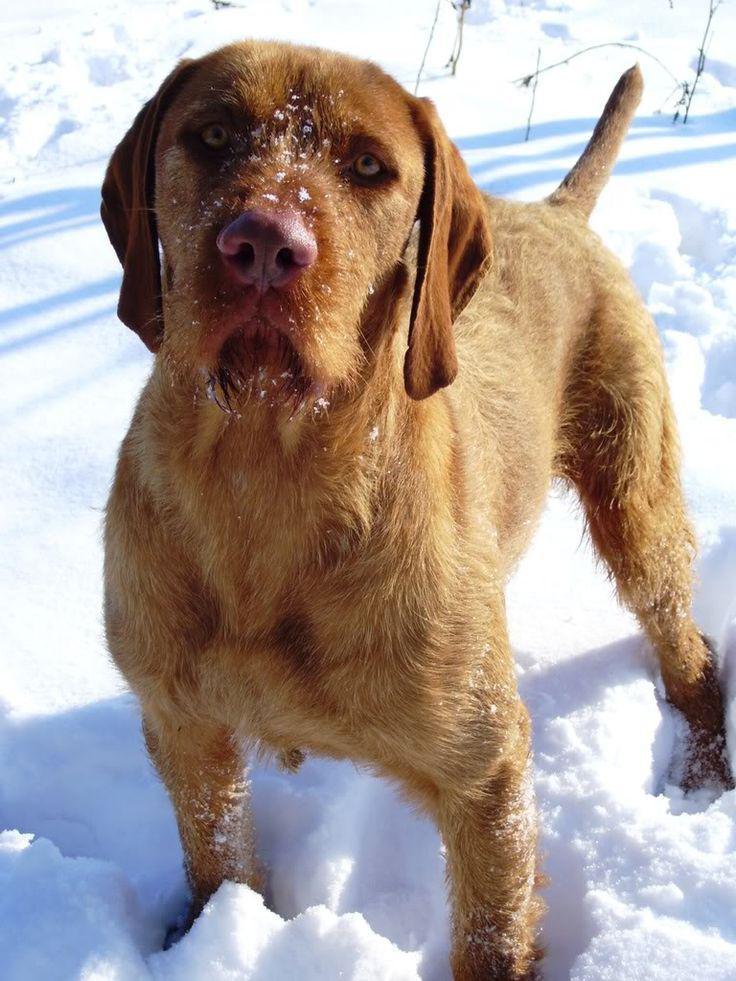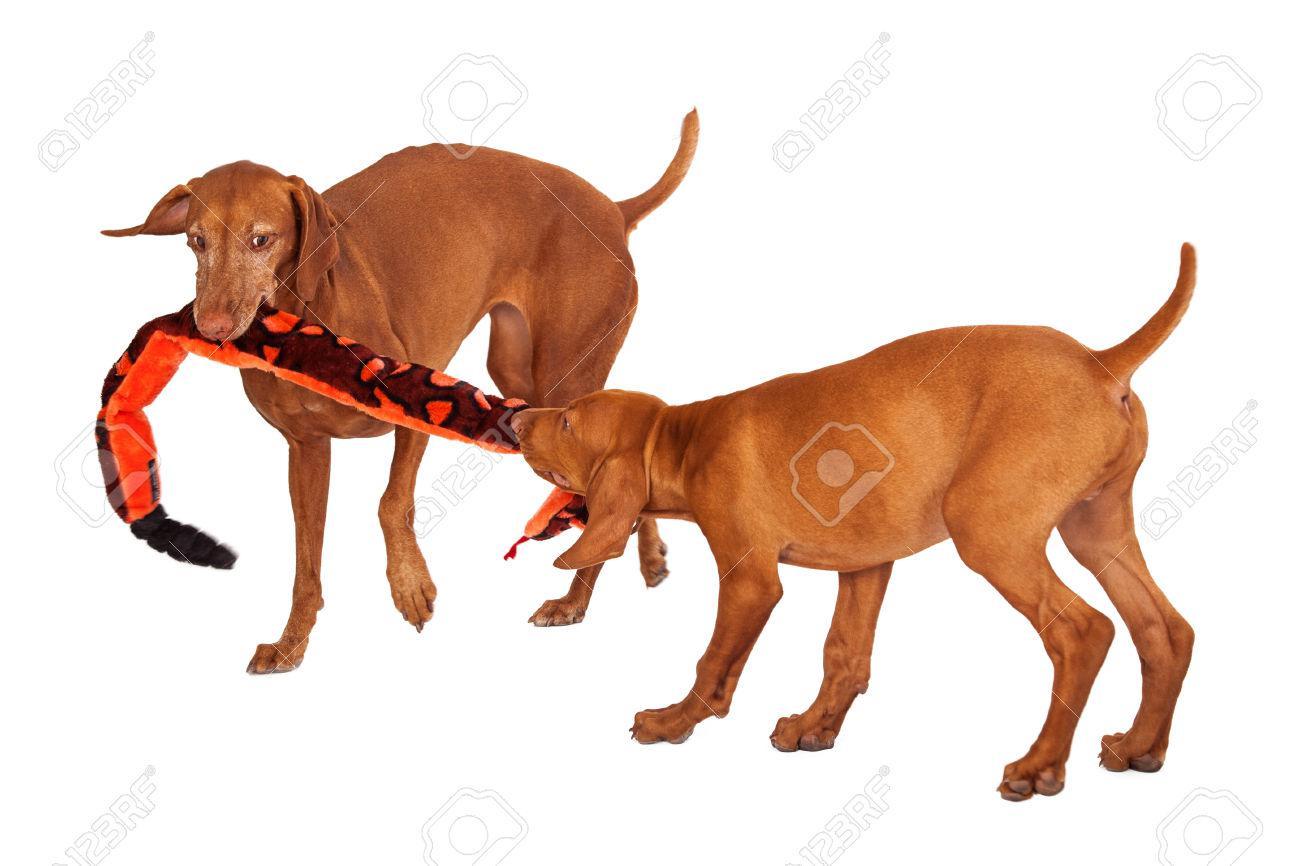The first image is the image on the left, the second image is the image on the right. Evaluate the accuracy of this statement regarding the images: "The dogs in the left and right images face toward each other, and the combined images include a chocolate lab and and a red-orange lab.". Is it true? Answer yes or no. No. The first image is the image on the left, the second image is the image on the right. For the images displayed, is the sentence "At least one of the dogs is wearing something." factually correct? Answer yes or no. No. 